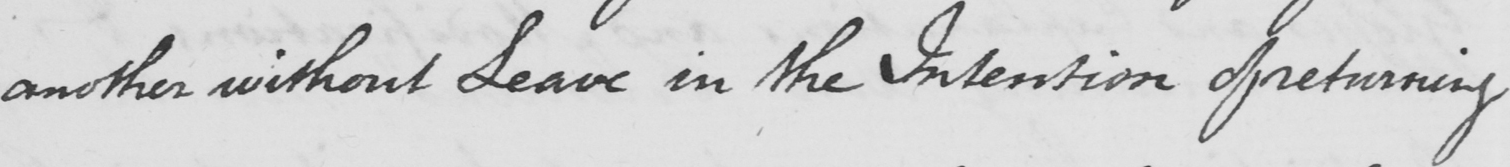What is written in this line of handwriting? another without Leave in the Intention of returning 